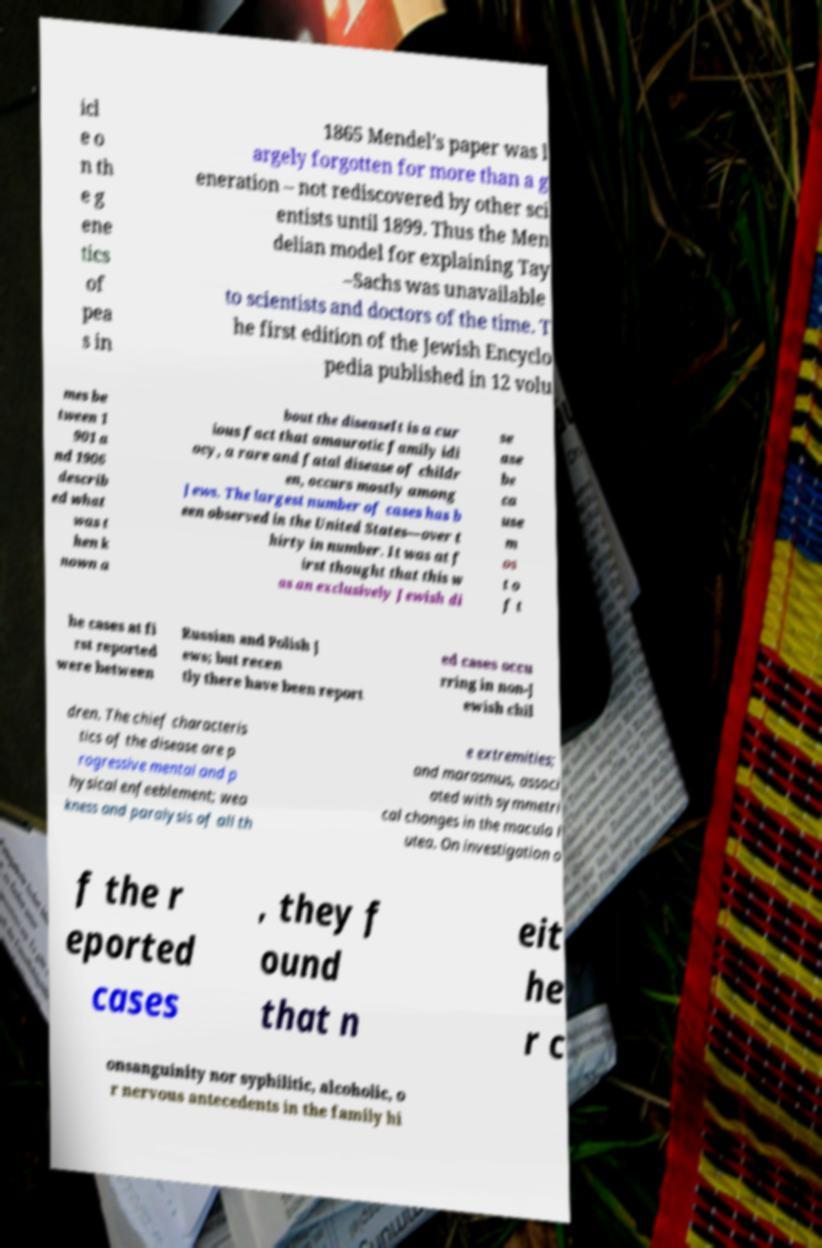Could you extract and type out the text from this image? icl e o n th e g ene tics of pea s in 1865 Mendel's paper was l argely forgotten for more than a g eneration – not rediscovered by other sci entists until 1899. Thus the Men delian model for explaining Tay –Sachs was unavailable to scientists and doctors of the time. T he first edition of the Jewish Encyclo pedia published in 12 volu mes be tween 1 901 a nd 1906 describ ed what was t hen k nown a bout the diseaseIt is a cur ious fact that amaurotic family idi ocy, a rare and fatal disease of childr en, occurs mostly among Jews. The largest number of cases has b een observed in the United States—over t hirty in number. It was at f irst thought that this w as an exclusively Jewish di se ase be ca use m os t o f t he cases at fi rst reported were between Russian and Polish J ews; but recen tly there have been report ed cases occu rring in non-J ewish chil dren. The chief characteris tics of the disease are p rogressive mental and p hysical enfeeblement; wea kness and paralysis of all th e extremities; and marasmus, associ ated with symmetri cal changes in the macula l utea. On investigation o f the r eported cases , they f ound that n eit he r c onsanguinity nor syphilitic, alcoholic, o r nervous antecedents in the family hi 